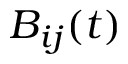<formula> <loc_0><loc_0><loc_500><loc_500>B _ { i j } ( t )</formula> 